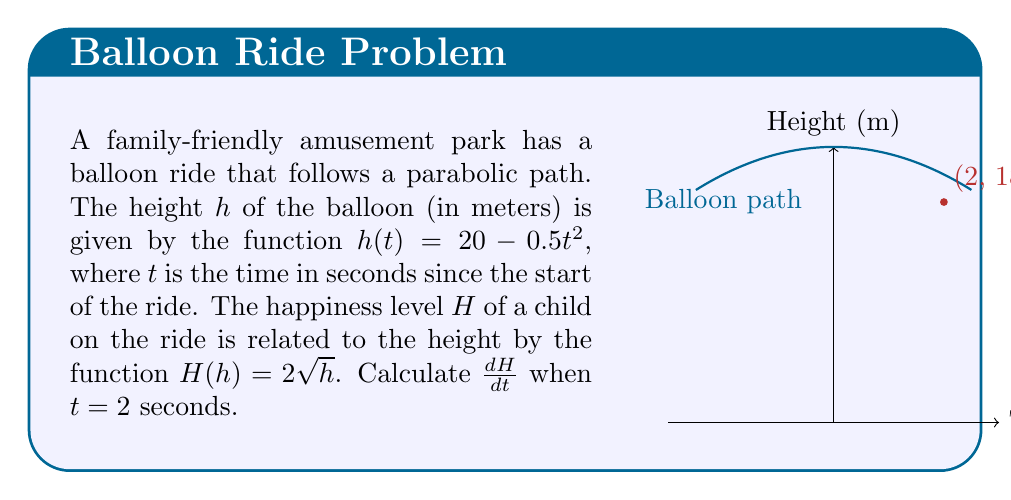Give your solution to this math problem. To solve this problem, we need to use the chain rule as we're dealing with a composite function. Let's break it down step-by-step:

1) We have two functions:
   $h(t) = 20 - 0.5t^2$ and $H(h) = 2\sqrt{h}$

2) We want to find $\frac{dH}{dt}$, which is the rate of change of happiness with respect to time.

3) By the chain rule:

   $$\frac{dH}{dt} = \frac{dH}{dh} \cdot \frac{dh}{dt}$$

4) Let's calculate each part:

   $\frac{dH}{dh} = \frac{d}{dh}(2\sqrt{h}) = \frac{1}{\sqrt{h}}$

   $\frac{dh}{dt} = \frac{d}{dt}(20 - 0.5t^2) = -t$

5) Now, let's substitute these back into the chain rule equation:

   $$\frac{dH}{dt} = \frac{1}{\sqrt{h}} \cdot (-t)$$

6) We need to evaluate this at $t = 2$. First, let's find $h$ when $t = 2$:

   $h(2) = 20 - 0.5(2)^2 = 20 - 2 = 18$

7) Now we can substitute everything:

   $$\frac{dH}{dt} = \frac{1}{\sqrt{18}} \cdot (-2)$$

8) Simplify:

   $$\frac{dH}{dt} = -\frac{2}{\sqrt{18}} = -\frac{2}{3\sqrt{2}}$$
Answer: $-\frac{2}{3\sqrt{2}}$ 